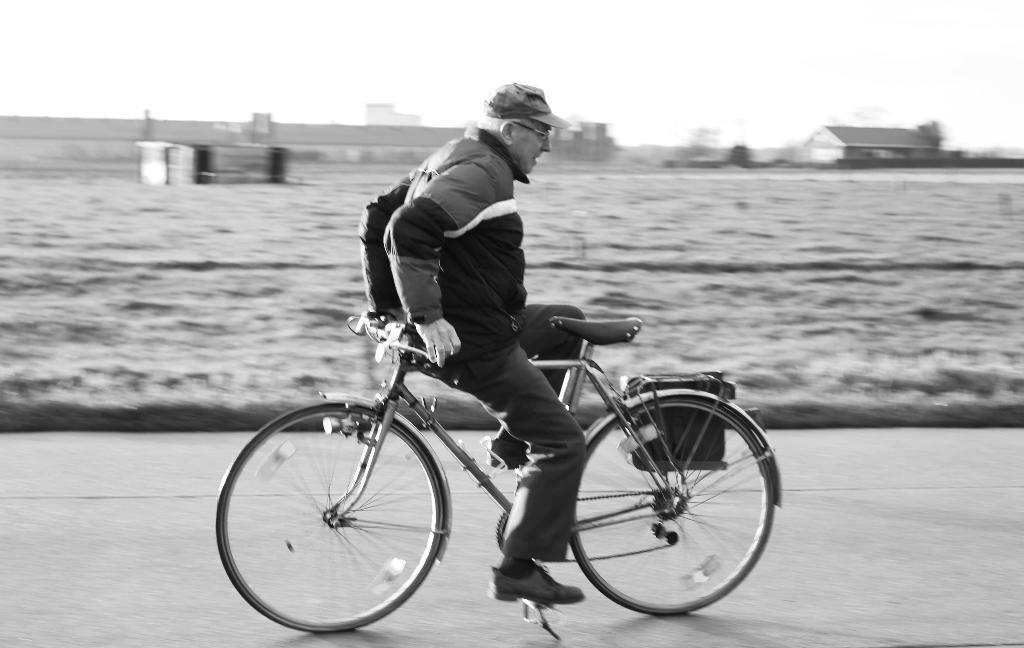What is the man in the image doing? The man is riding a bicycle in the image. What is the man wearing on his head? The man is wearing a cap. What can be seen in the background of the image? There is sky and a house visible in the background of the image. How does the man rub the coach in the image? There is no coach or rubbing action present in the image; the man is simply riding a bicycle. 